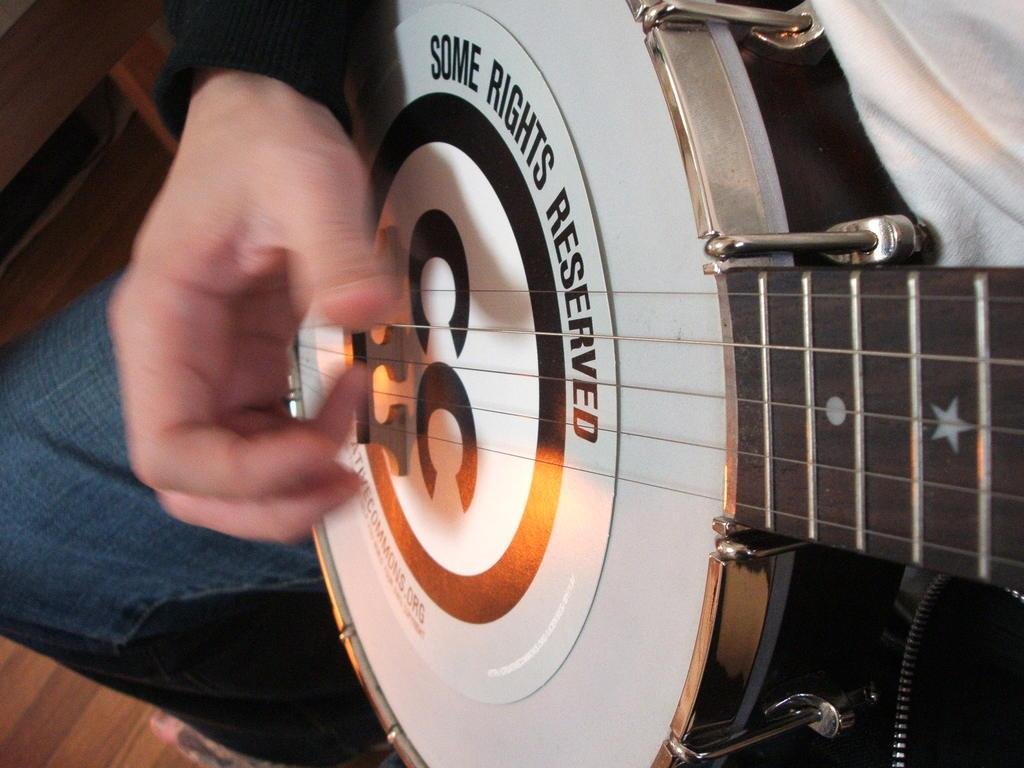What is the main subject of the image? There is a person in the image. What is the person holding in his hand? The person is holding a guitar in his hand. How many jellyfish can be seen swimming in the image? There are no jellyfish present in the image. What color is the person's lipstick in the image? There is no mention of lipstick or any specific color on the person's lips in the image. 